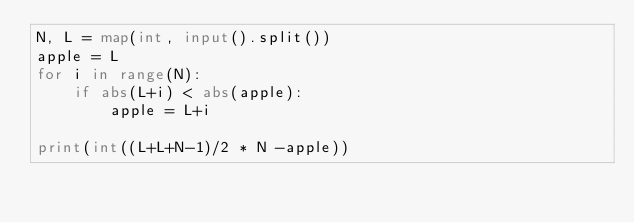<code> <loc_0><loc_0><loc_500><loc_500><_Python_>N, L = map(int, input().split())
apple = L
for i in range(N):
    if abs(L+i) < abs(apple):
        apple = L+i
    
print(int((L+L+N-1)/2 * N -apple))</code> 